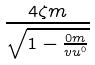Convert formula to latex. <formula><loc_0><loc_0><loc_500><loc_500>\frac { 4 \zeta m } { \sqrt { 1 - \frac { 0 m } { v u ^ { 0 } } } }</formula> 